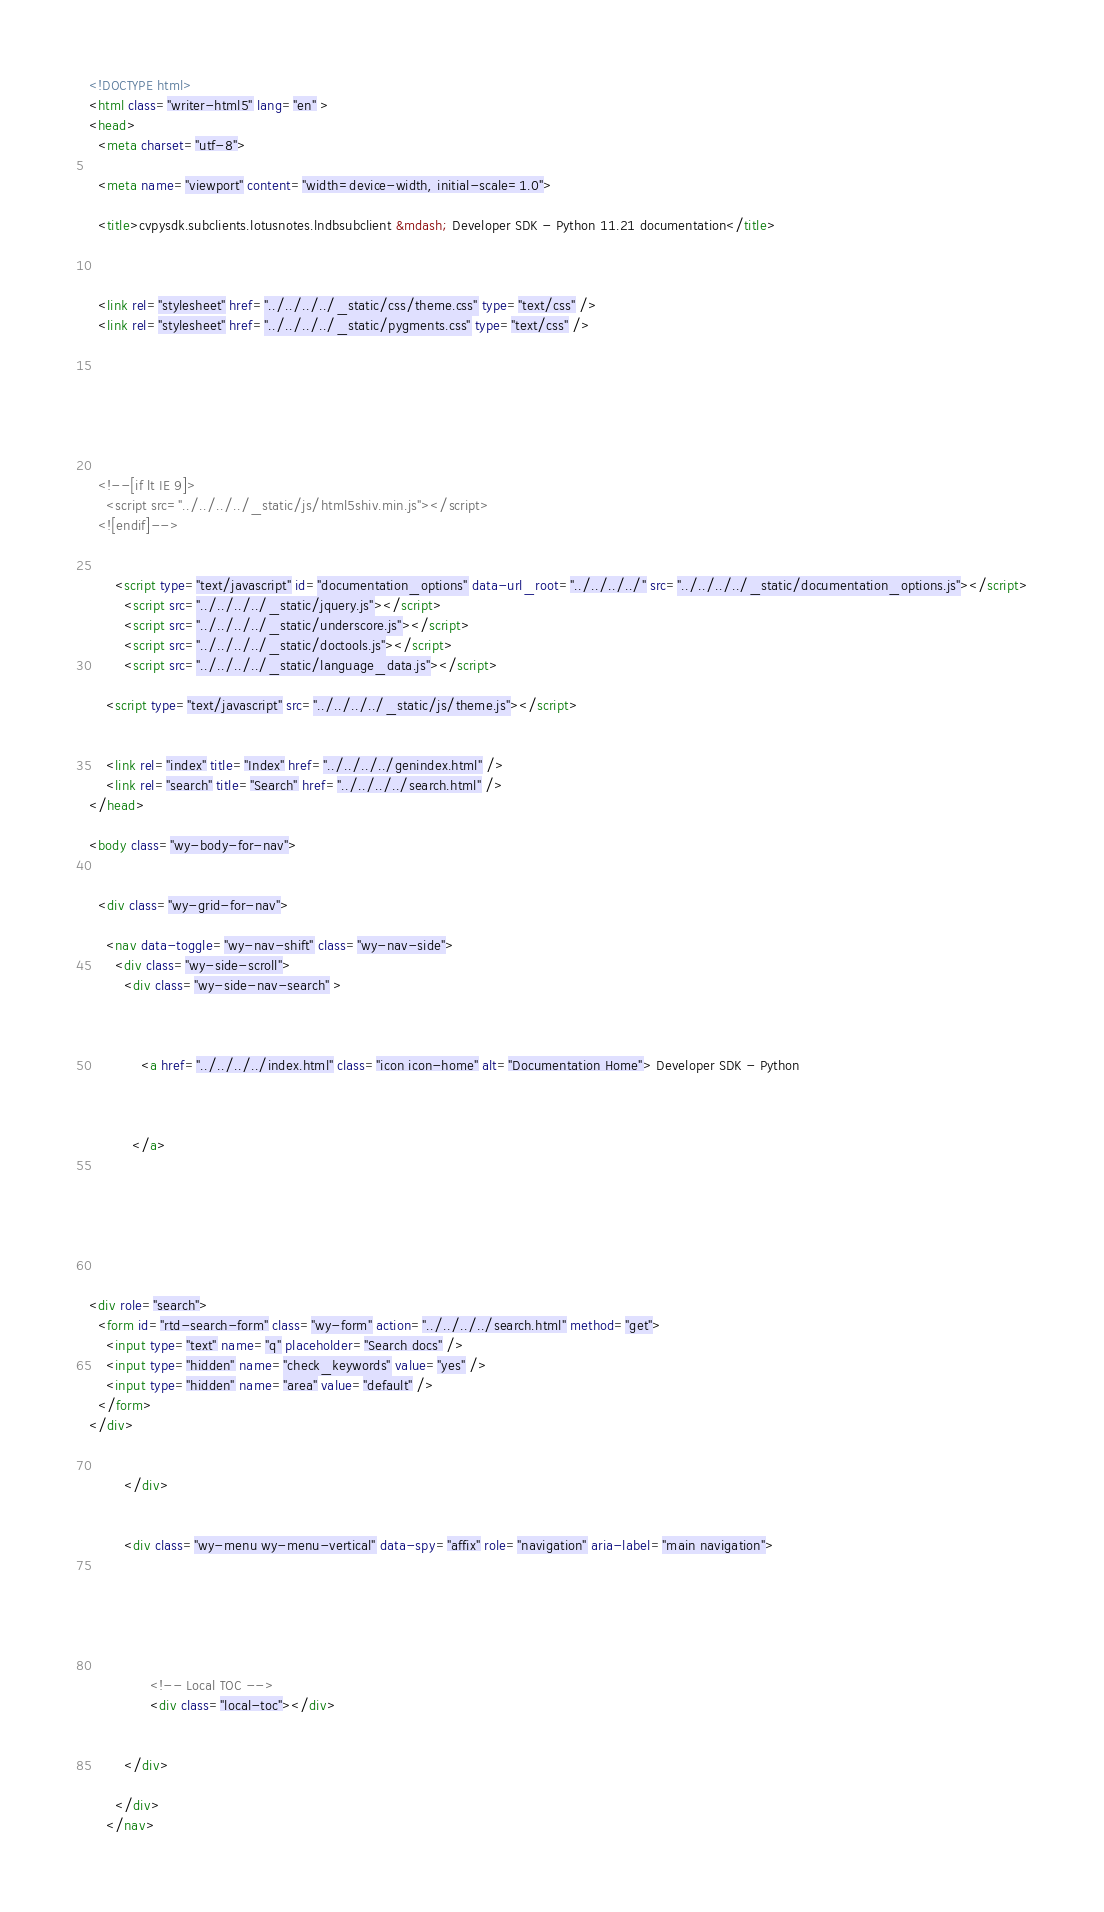Convert code to text. <code><loc_0><loc_0><loc_500><loc_500><_HTML_>

<!DOCTYPE html>
<html class="writer-html5" lang="en" >
<head>
  <meta charset="utf-8">
  
  <meta name="viewport" content="width=device-width, initial-scale=1.0">
  
  <title>cvpysdk.subclients.lotusnotes.lndbsubclient &mdash; Developer SDK - Python 11.21 documentation</title>
  

  
  <link rel="stylesheet" href="../../../../_static/css/theme.css" type="text/css" />
  <link rel="stylesheet" href="../../../../_static/pygments.css" type="text/css" />

  
  
  
  

  
  <!--[if lt IE 9]>
    <script src="../../../../_static/js/html5shiv.min.js"></script>
  <![endif]-->
  
    
      <script type="text/javascript" id="documentation_options" data-url_root="../../../../" src="../../../../_static/documentation_options.js"></script>
        <script src="../../../../_static/jquery.js"></script>
        <script src="../../../../_static/underscore.js"></script>
        <script src="../../../../_static/doctools.js"></script>
        <script src="../../../../_static/language_data.js"></script>
    
    <script type="text/javascript" src="../../../../_static/js/theme.js"></script>

    
    <link rel="index" title="Index" href="../../../../genindex.html" />
    <link rel="search" title="Search" href="../../../../search.html" /> 
</head>

<body class="wy-body-for-nav">

   
  <div class="wy-grid-for-nav">
    
    <nav data-toggle="wy-nav-shift" class="wy-nav-side">
      <div class="wy-side-scroll">
        <div class="wy-side-nav-search" >
          

          
            <a href="../../../../index.html" class="icon icon-home" alt="Documentation Home"> Developer SDK - Python
          

          
          </a>

          
            
            
          

          
<div role="search">
  <form id="rtd-search-form" class="wy-form" action="../../../../search.html" method="get">
    <input type="text" name="q" placeholder="Search docs" />
    <input type="hidden" name="check_keywords" value="yes" />
    <input type="hidden" name="area" value="default" />
  </form>
</div>

          
        </div>

        
        <div class="wy-menu wy-menu-vertical" data-spy="affix" role="navigation" aria-label="main navigation">
          
            
            
              
            
            
              <!-- Local TOC -->
              <div class="local-toc"></div>
            
          
        </div>
        
      </div>
    </nav>
</code> 